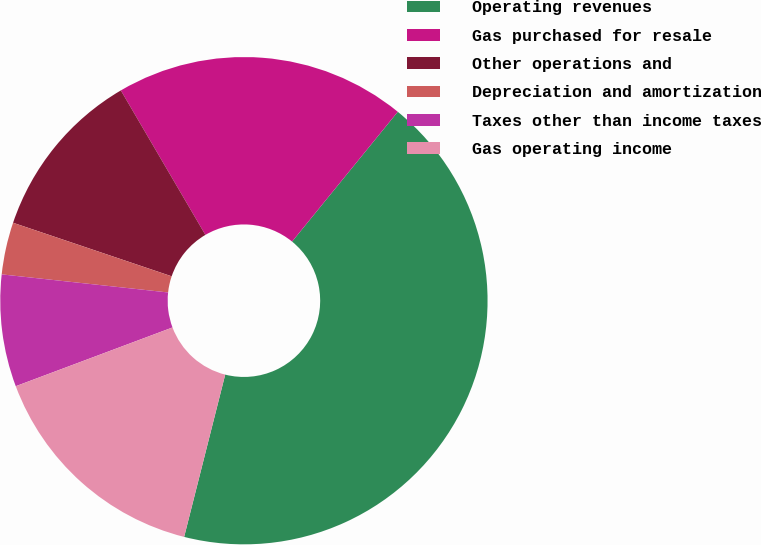Convert chart. <chart><loc_0><loc_0><loc_500><loc_500><pie_chart><fcel>Operating revenues<fcel>Gas purchased for resale<fcel>Other operations and<fcel>Depreciation and amortization<fcel>Taxes other than income taxes<fcel>Gas operating income<nl><fcel>43.07%<fcel>19.31%<fcel>11.39%<fcel>3.46%<fcel>7.43%<fcel>15.35%<nl></chart> 